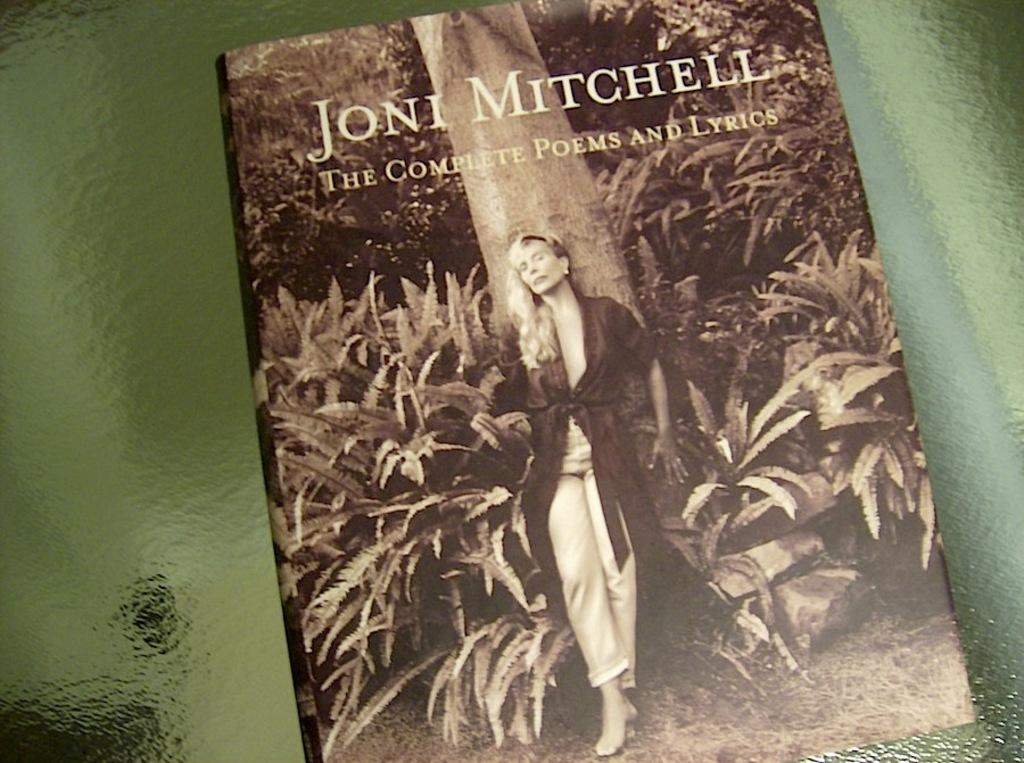<image>
Share a concise interpretation of the image provided. A book by Joni Mitchell is siting on top of a glass table 